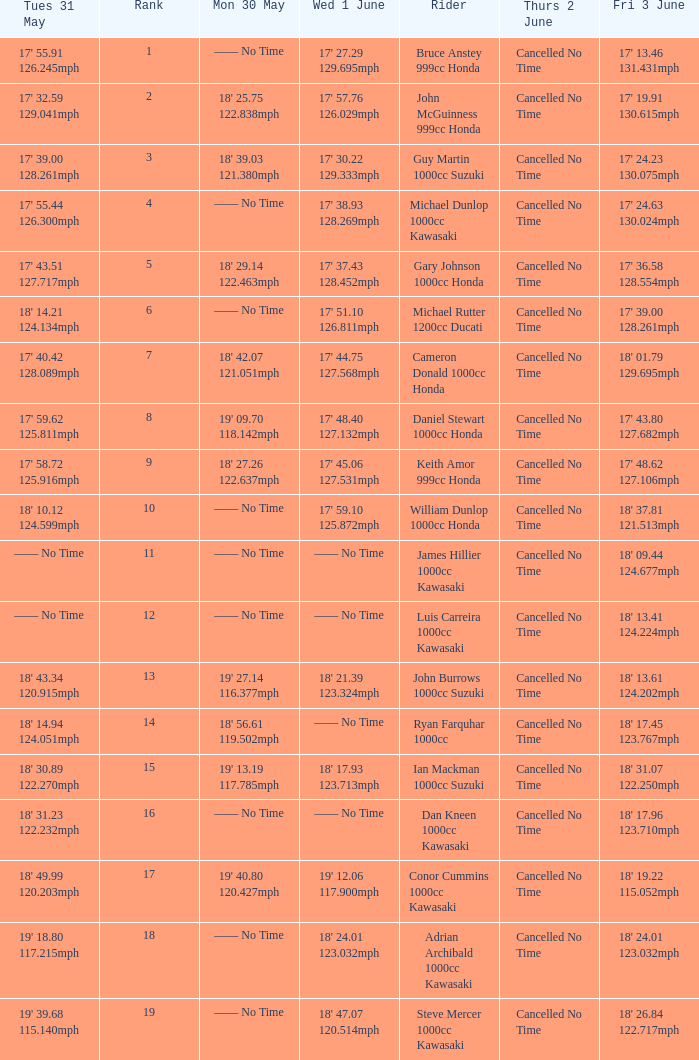What is the Thurs 2 June time for the rider with a Fri 3 June time of 17' 36.58 128.554mph? Cancelled No Time. 